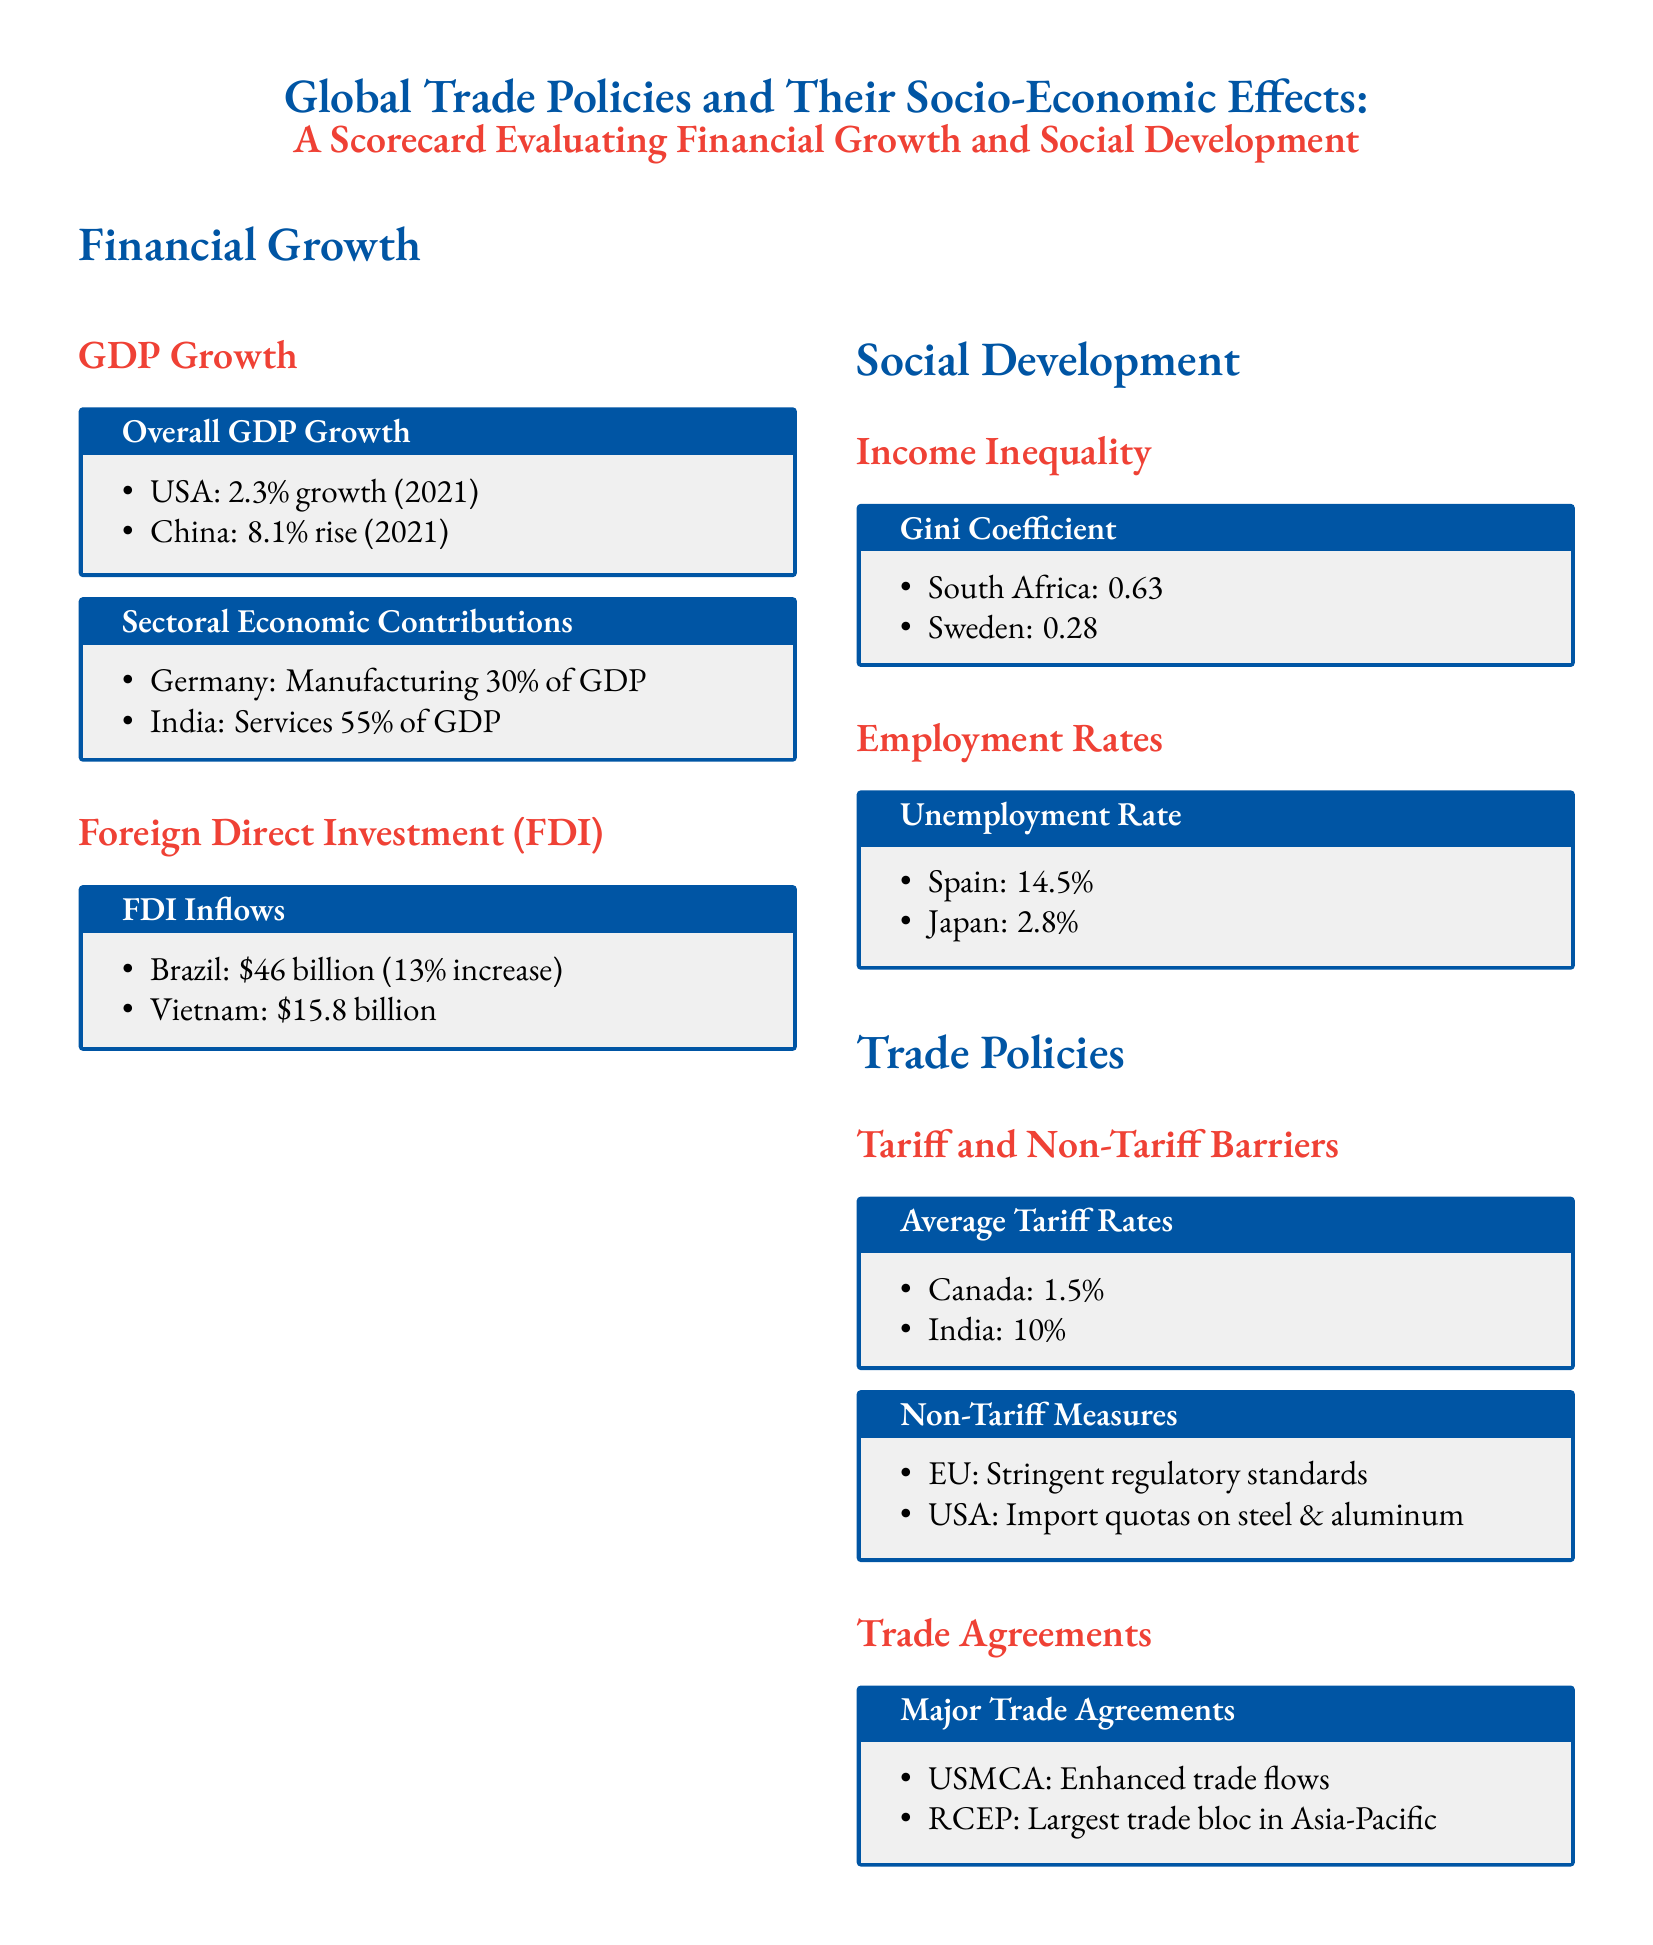What was the GDP growth rate in China in 2021? The document states that China experienced an 8.1% rise in GDP growth in 2021.
Answer: 8.1% What is the Gini coefficient for Sweden? The scorecard lists Sweden's Gini coefficient as 0.28.
Answer: 0.28 What percentage of Germany's GDP is contributed by the manufacturing sector? According to the scorecard, Germany's manufacturing sector contributes 30% of GDP.
Answer: 30% What was the unemployment rate in Japan? The document indicates that Japan's unemployment rate is 2.8%.
Answer: 2.8% Which major trade agreement is noted for enhancing trade flows? The scorecard mentions USMCA as a major trade agreement enhancing trade flows.
Answer: USMCA What was Brazil's Foreign Direct Investment inflow amount? The document states that Brazil had FDI inflows of $46 billion.
Answer: $46 billion Which country has the highest Gini coefficient listed in the document? The scorecard identifies South Africa with a Gini coefficient of 0.63 as the highest mentioned.
Answer: South Africa What is the average tariff rate for Canada? The document lists Canada's average tariff rate as 1.5%.
Answer: 1.5% How much did Vietnam attract in FDI? According to the scorecard, Vietnam attracted $15.8 billion in FDI.
Answer: $15.8 billion 